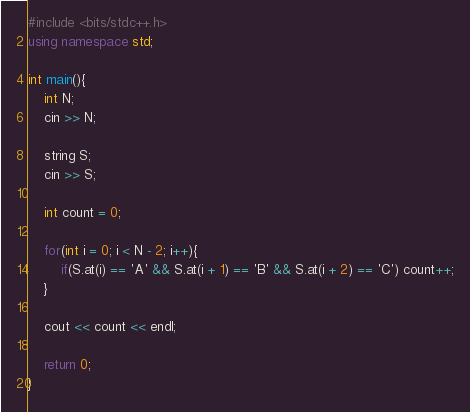Convert code to text. <code><loc_0><loc_0><loc_500><loc_500><_C++_>#include <bits/stdc++.h>
using namespace std;

int main(){
    int N;
    cin >> N;

    string S;
    cin >> S;

    int count = 0;

    for(int i = 0; i < N - 2; i++){
        if(S.at(i) == 'A' && S.at(i + 1) == 'B' && S.at(i + 2) == 'C') count++;
    }

    cout << count << endl;

    return 0;
}</code> 